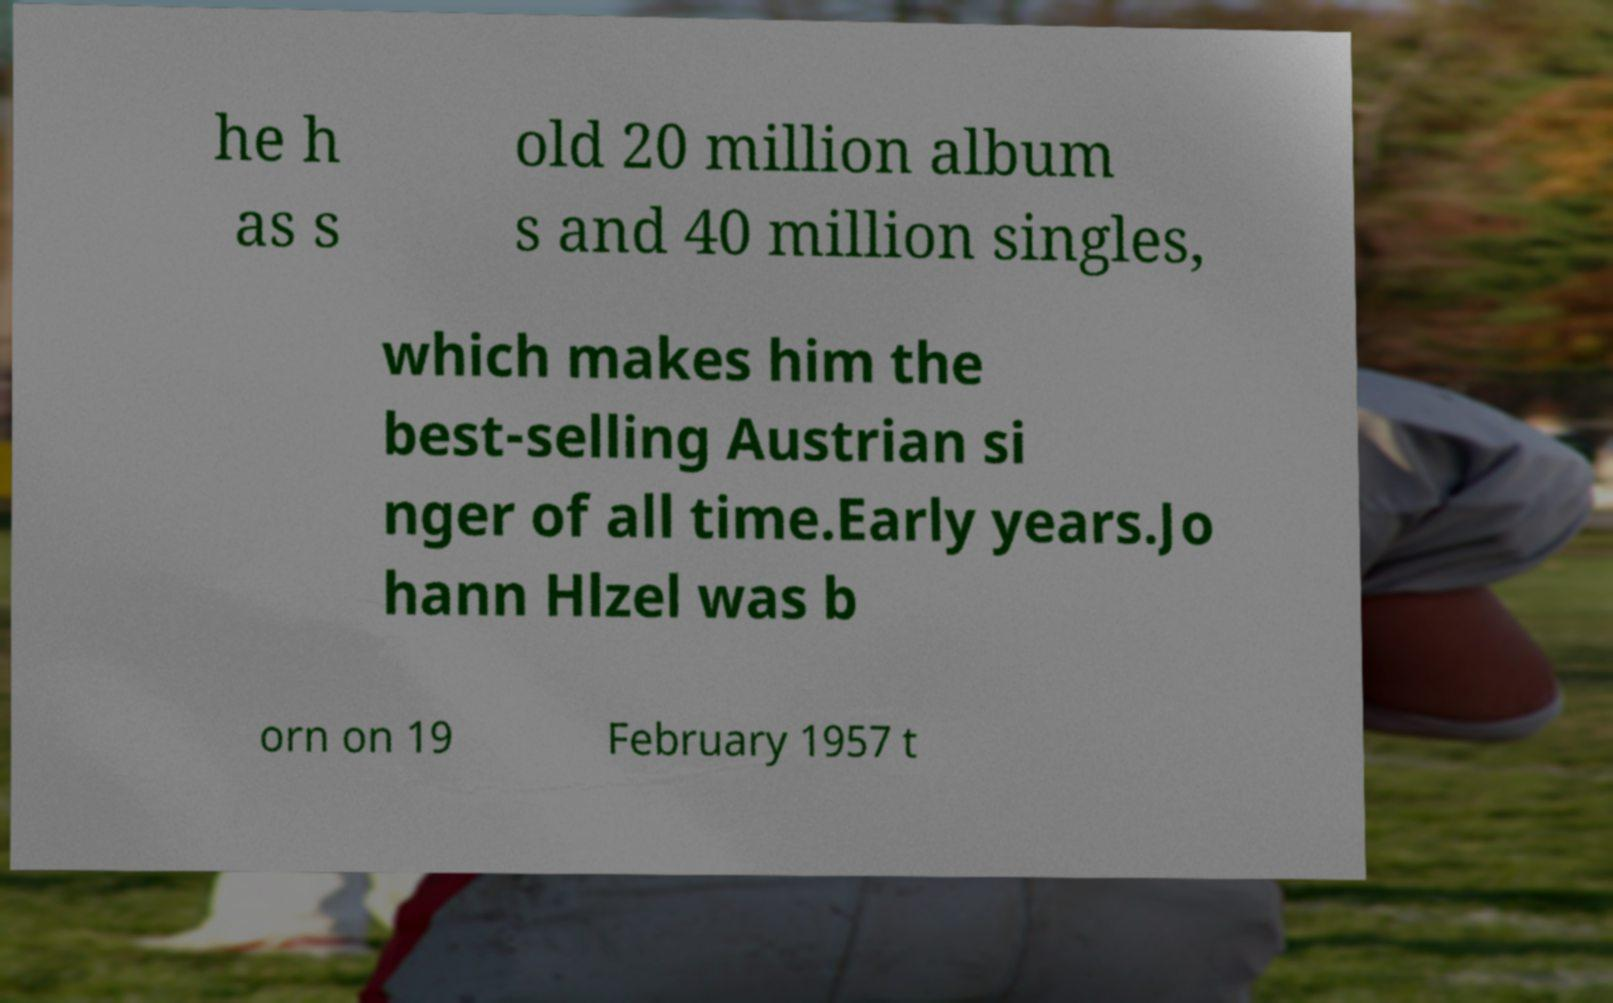There's text embedded in this image that I need extracted. Can you transcribe it verbatim? he h as s old 20 million album s and 40 million singles, which makes him the best-selling Austrian si nger of all time.Early years.Jo hann Hlzel was b orn on 19 February 1957 t 